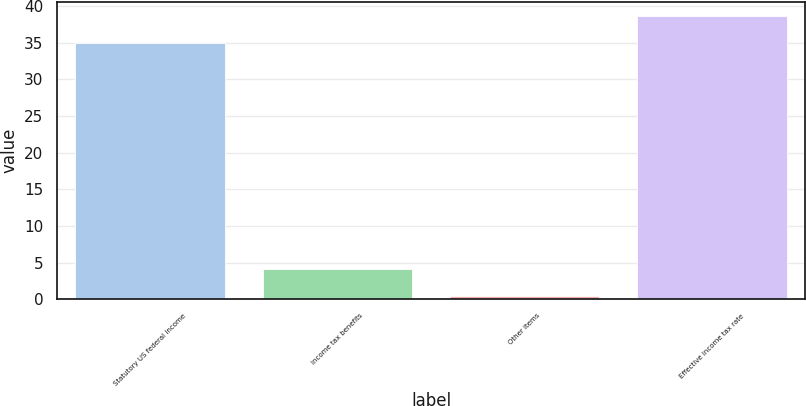Convert chart to OTSL. <chart><loc_0><loc_0><loc_500><loc_500><bar_chart><fcel>Statutory US federal income<fcel>income tax benefits<fcel>Other items<fcel>Effective income tax rate<nl><fcel>35<fcel>4.13<fcel>0.5<fcel>38.63<nl></chart> 